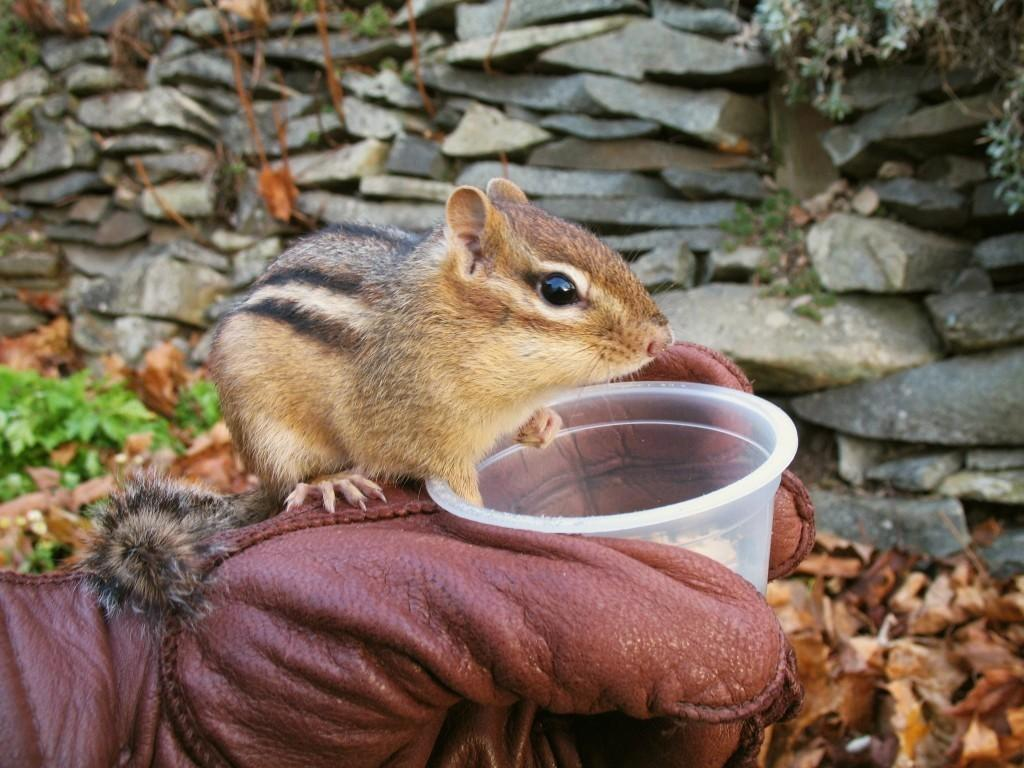Who is present in the image? There is a person in the image. What is the person holding? The person is holding a glass. What animal is on the person's hand? There is a squirrel on the person's hand. What can be seen in the background of the image? There are stones, leaves, and dry leaves in the background of the image. What type of alley can be seen in the image? There is no alley present in the image. What part of the person's body is holding the glass? The person's hand is holding the glass, not their thumb. 